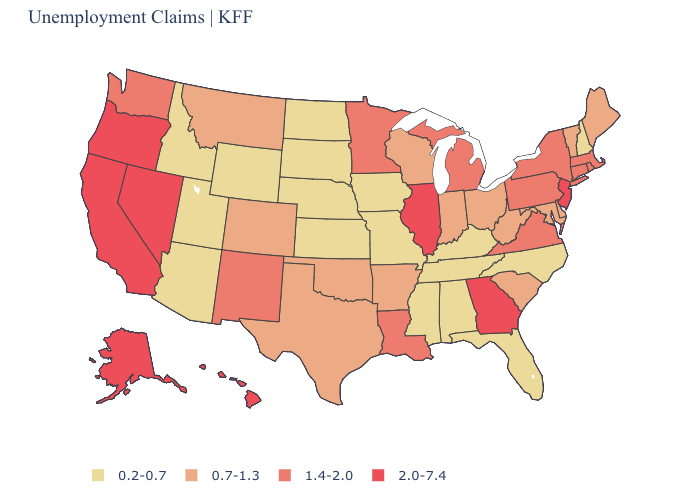What is the lowest value in states that border Idaho?
Write a very short answer. 0.2-0.7. What is the lowest value in the USA?
Write a very short answer. 0.2-0.7. Name the states that have a value in the range 0.2-0.7?
Write a very short answer. Alabama, Arizona, Florida, Idaho, Iowa, Kansas, Kentucky, Mississippi, Missouri, Nebraska, New Hampshire, North Carolina, North Dakota, South Dakota, Tennessee, Utah, Wyoming. How many symbols are there in the legend?
Be succinct. 4. Does Connecticut have the same value as Maine?
Write a very short answer. No. What is the highest value in states that border Georgia?
Give a very brief answer. 0.7-1.3. What is the value of North Dakota?
Answer briefly. 0.2-0.7. Among the states that border Iowa , does Missouri have the highest value?
Quick response, please. No. Name the states that have a value in the range 1.4-2.0?
Short answer required. Connecticut, Louisiana, Massachusetts, Michigan, Minnesota, New Mexico, New York, Pennsylvania, Rhode Island, Virginia, Washington. How many symbols are there in the legend?
Keep it brief. 4. Is the legend a continuous bar?
Answer briefly. No. Among the states that border South Carolina , does Georgia have the lowest value?
Quick response, please. No. What is the value of South Dakota?
Quick response, please. 0.2-0.7. Name the states that have a value in the range 1.4-2.0?
Concise answer only. Connecticut, Louisiana, Massachusetts, Michigan, Minnesota, New Mexico, New York, Pennsylvania, Rhode Island, Virginia, Washington. Name the states that have a value in the range 2.0-7.4?
Keep it brief. Alaska, California, Georgia, Hawaii, Illinois, Nevada, New Jersey, Oregon. 